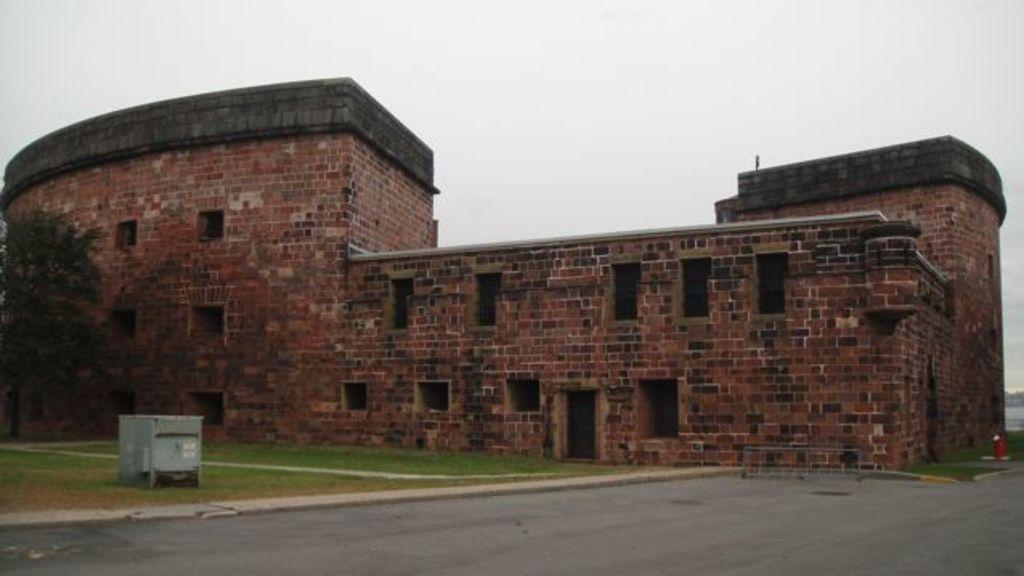What type of surface can be seen in the image? There is a road in the image. What type of vegetation is present in the image? There is grass in the image. What type of natural structure is visible in the image? There is a tree in the image. What type of man-made structure is visible in the image? There is a building in the image. What else can be seen in the image besides the road, grass, tree, and building? There are objects in the image. What is visible in the background of the image? The sky is visible in the background of the image. How many clocks are hanging on the tree in the image? There are no clocks present in the image, and therefore no such objects can be observed on the tree. What type of powder is covering the grass in the image? There is no powder covering the grass in the image; the grass appears to be natural and unaltered. 